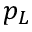<formula> <loc_0><loc_0><loc_500><loc_500>p _ { L }</formula> 